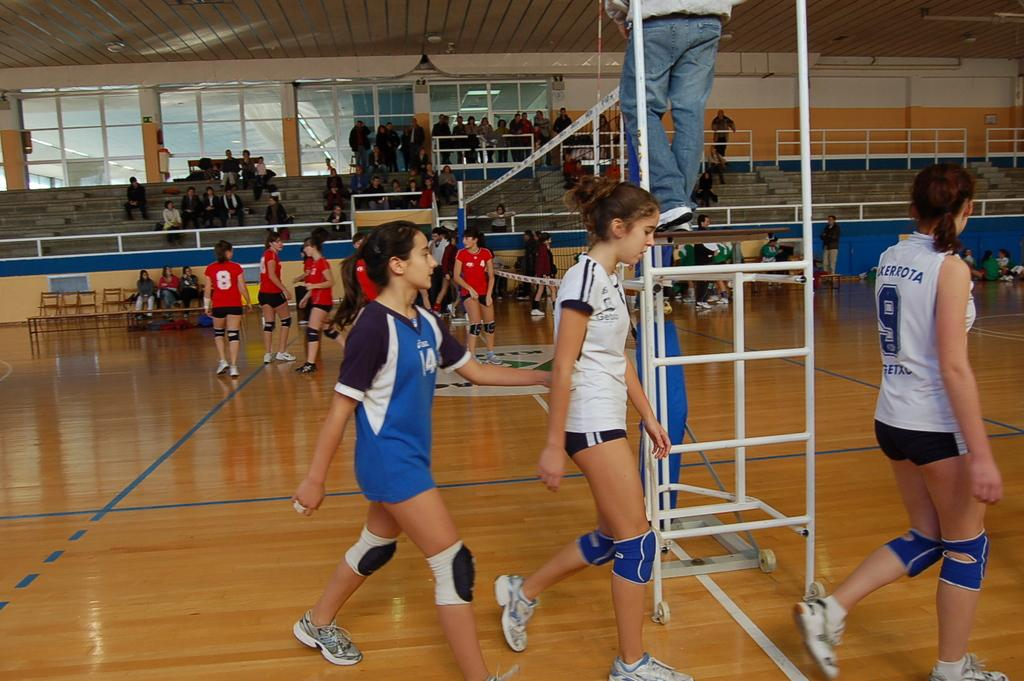What are the people in the image wearing? The people in the image are wearing sports dress. What can be seen attached to poles in the image? There is a net attached to poles in the image. Can you describe the people in the background of the image? The people in the background are in a stadium. What type of skirt is the basketball wearing in the image? There is no basketball present in the image, and therefore no skirt can be observed. 